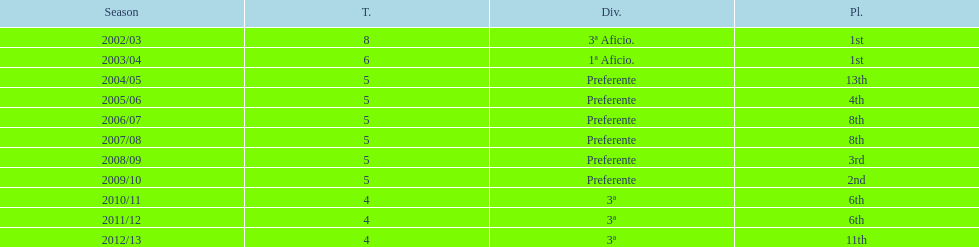Which division placed more than aficio 1a and 3a? Preferente. 